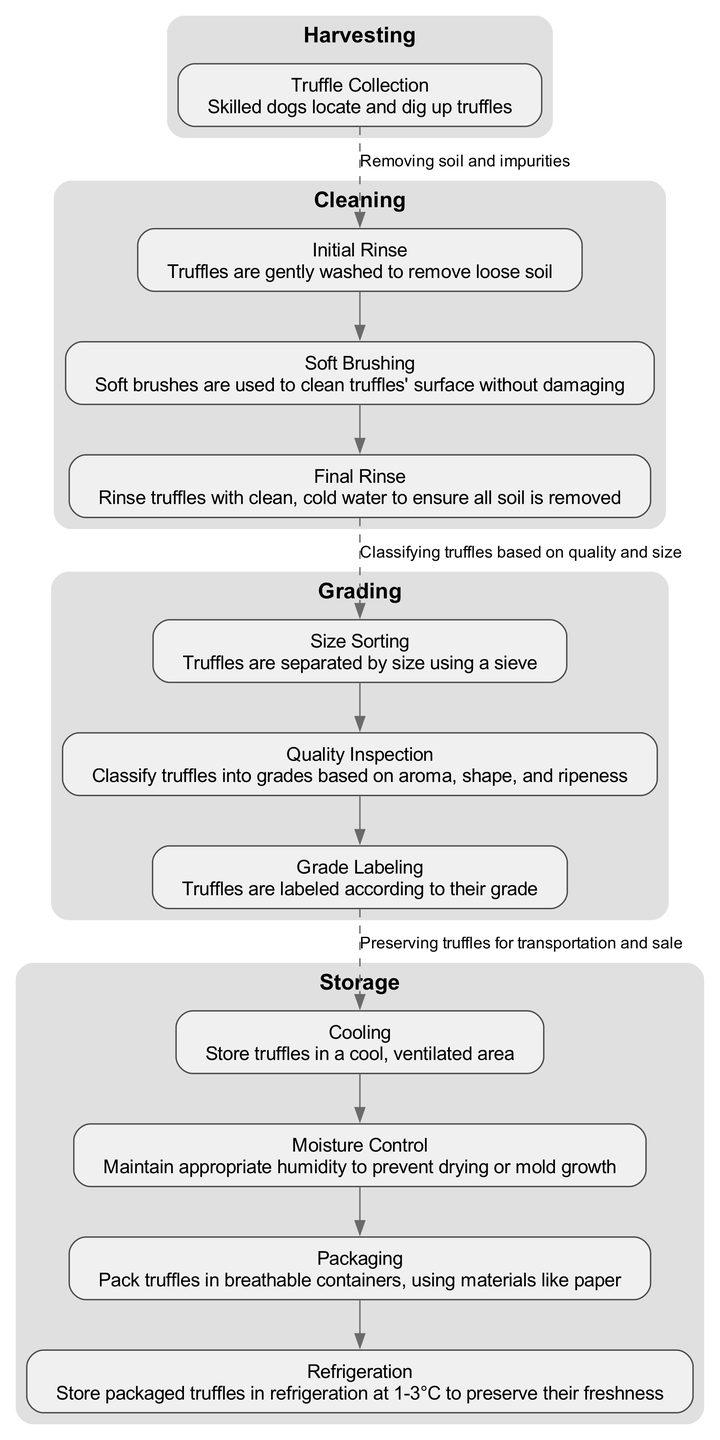What is the first step in the post-harvest processing of truffles? The first step listed in the diagram is "Harvesting," as it is the initial action taken before other steps can occur.
Answer: Harvesting How many nodes are there in the Cleaning step? The Cleaning step consists of three nodes: Initial Rinse, Soft Brushing, and Final Rinse. By counting these nodes, we find that there are a total of three in this step.
Answer: 3 What node follows the Initial Rinse in the Cleaning step? The node that directly follows the Initial Rinse in the Cleaning step is Soft Brushing, as per the flow indicated in the diagram.
Answer: Soft Brushing Which step involves Quality Inspection? Quality Inspection is part of the Grading step, where truffles are inspected and classified based on their aroma, shape, and ripeness. This can be derived from the flow of steps in the diagram.
Answer: Grading What is the final step before truffles are refrigerated? The final step before refrigeration is Packaging, where truffles are packed in breathable containers. This is located right before the Refrigeration node in the Storage step.
Answer: Packaging How many nodes are there in the Storage step? The Storage step contains four nodes: Cooling, Moisture Control, Packaging, and Refrigeration. Therefore, the total number of nodes in this step is four.
Answer: 4 What does the dashed line indicate between steps? The dashed line indicates a connection between the last node of one step and the first node of the next step, showing the transition between processes in the diagram.
Answer: Transition between steps Which step focuses on preserving truffles for sale? The step that is primarily focused on preserving truffles for sale is Storage, as this step encompasses actions necessary for extending the freshness of truffles during transport.
Answer: Storage What is the relationship between Size Sorting and Grade Labeling? Size Sorting is a node in the Grading step and occurs before Grade Labeling; this indicates that the sorting of truffles by size is a prerequisite for labeling them according to grade.
Answer: Size Sorting occurs before Grade Labeling 